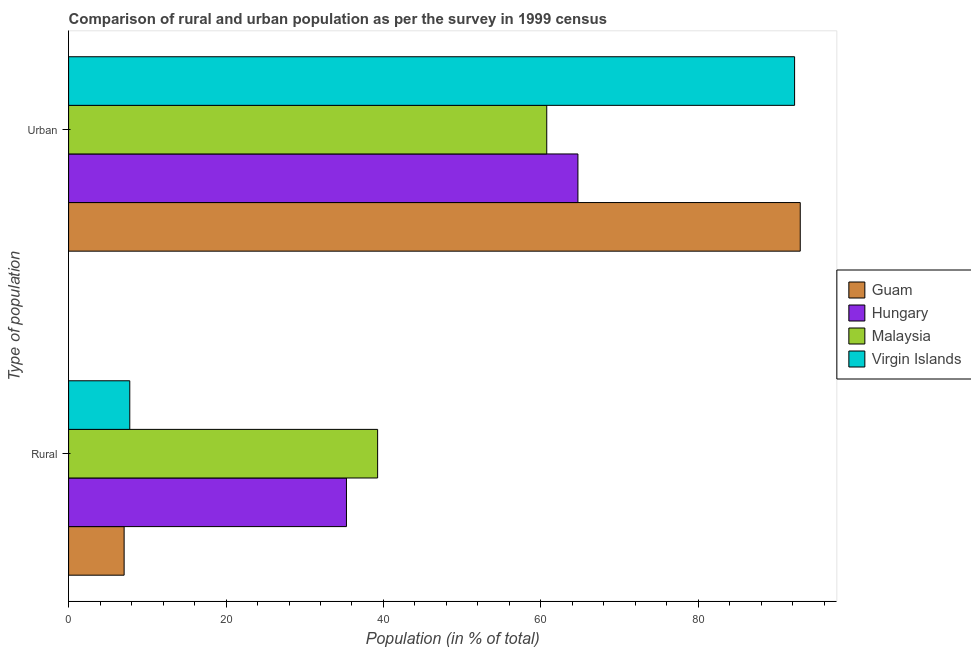How many different coloured bars are there?
Make the answer very short. 4. Are the number of bars on each tick of the Y-axis equal?
Make the answer very short. Yes. How many bars are there on the 1st tick from the top?
Your answer should be compact. 4. What is the label of the 1st group of bars from the top?
Your answer should be compact. Urban. What is the rural population in Virgin Islands?
Give a very brief answer. 7.77. Across all countries, what is the maximum rural population?
Your response must be concise. 39.26. Across all countries, what is the minimum rural population?
Your answer should be compact. 7.05. In which country was the rural population maximum?
Provide a succinct answer. Malaysia. In which country was the rural population minimum?
Offer a terse response. Guam. What is the total urban population in the graph?
Give a very brief answer. 310.62. What is the difference between the urban population in Guam and that in Hungary?
Your response must be concise. 28.24. What is the difference between the rural population in Malaysia and the urban population in Virgin Islands?
Your answer should be compact. -52.97. What is the average rural population per country?
Your answer should be compact. 22.35. What is the difference between the rural population and urban population in Guam?
Provide a short and direct response. -85.89. What is the ratio of the rural population in Hungary to that in Malaysia?
Make the answer very short. 0.9. What does the 1st bar from the top in Urban represents?
Offer a very short reply. Virgin Islands. What does the 1st bar from the bottom in Urban represents?
Make the answer very short. Guam. Are all the bars in the graph horizontal?
Your answer should be compact. Yes. What is the difference between two consecutive major ticks on the X-axis?
Ensure brevity in your answer.  20. Does the graph contain any zero values?
Ensure brevity in your answer.  No. Does the graph contain grids?
Offer a very short reply. No. Where does the legend appear in the graph?
Provide a succinct answer. Center right. How are the legend labels stacked?
Ensure brevity in your answer.  Vertical. What is the title of the graph?
Provide a short and direct response. Comparison of rural and urban population as per the survey in 1999 census. What is the label or title of the X-axis?
Ensure brevity in your answer.  Population (in % of total). What is the label or title of the Y-axis?
Your answer should be compact. Type of population. What is the Population (in % of total) in Guam in Rural?
Offer a terse response. 7.05. What is the Population (in % of total) of Hungary in Rural?
Give a very brief answer. 35.3. What is the Population (in % of total) of Malaysia in Rural?
Your response must be concise. 39.26. What is the Population (in % of total) of Virgin Islands in Rural?
Your response must be concise. 7.77. What is the Population (in % of total) in Guam in Urban?
Ensure brevity in your answer.  92.95. What is the Population (in % of total) of Hungary in Urban?
Your answer should be compact. 64.7. What is the Population (in % of total) of Malaysia in Urban?
Provide a short and direct response. 60.74. What is the Population (in % of total) in Virgin Islands in Urban?
Offer a very short reply. 92.23. Across all Type of population, what is the maximum Population (in % of total) in Guam?
Offer a very short reply. 92.95. Across all Type of population, what is the maximum Population (in % of total) of Hungary?
Provide a short and direct response. 64.7. Across all Type of population, what is the maximum Population (in % of total) in Malaysia?
Your response must be concise. 60.74. Across all Type of population, what is the maximum Population (in % of total) of Virgin Islands?
Provide a short and direct response. 92.23. Across all Type of population, what is the minimum Population (in % of total) of Guam?
Your response must be concise. 7.05. Across all Type of population, what is the minimum Population (in % of total) of Hungary?
Keep it short and to the point. 35.3. Across all Type of population, what is the minimum Population (in % of total) of Malaysia?
Your response must be concise. 39.26. Across all Type of population, what is the minimum Population (in % of total) in Virgin Islands?
Keep it short and to the point. 7.77. What is the total Population (in % of total) in Hungary in the graph?
Provide a short and direct response. 100. What is the difference between the Population (in % of total) in Guam in Rural and that in Urban?
Provide a succinct answer. -85.89. What is the difference between the Population (in % of total) of Hungary in Rural and that in Urban?
Give a very brief answer. -29.4. What is the difference between the Population (in % of total) in Malaysia in Rural and that in Urban?
Provide a succinct answer. -21.48. What is the difference between the Population (in % of total) in Virgin Islands in Rural and that in Urban?
Make the answer very short. -84.46. What is the difference between the Population (in % of total) in Guam in Rural and the Population (in % of total) in Hungary in Urban?
Make the answer very short. -57.65. What is the difference between the Population (in % of total) of Guam in Rural and the Population (in % of total) of Malaysia in Urban?
Provide a succinct answer. -53.69. What is the difference between the Population (in % of total) of Guam in Rural and the Population (in % of total) of Virgin Islands in Urban?
Make the answer very short. -85.17. What is the difference between the Population (in % of total) of Hungary in Rural and the Population (in % of total) of Malaysia in Urban?
Give a very brief answer. -25.44. What is the difference between the Population (in % of total) in Hungary in Rural and the Population (in % of total) in Virgin Islands in Urban?
Ensure brevity in your answer.  -56.93. What is the difference between the Population (in % of total) in Malaysia in Rural and the Population (in % of total) in Virgin Islands in Urban?
Provide a short and direct response. -52.97. What is the average Population (in % of total) of Hungary per Type of population?
Provide a succinct answer. 50. What is the difference between the Population (in % of total) in Guam and Population (in % of total) in Hungary in Rural?
Offer a terse response. -28.24. What is the difference between the Population (in % of total) of Guam and Population (in % of total) of Malaysia in Rural?
Your response must be concise. -32.2. What is the difference between the Population (in % of total) in Guam and Population (in % of total) in Virgin Islands in Rural?
Give a very brief answer. -0.72. What is the difference between the Population (in % of total) of Hungary and Population (in % of total) of Malaysia in Rural?
Offer a terse response. -3.96. What is the difference between the Population (in % of total) in Hungary and Population (in % of total) in Virgin Islands in Rural?
Make the answer very short. 27.53. What is the difference between the Population (in % of total) in Malaysia and Population (in % of total) in Virgin Islands in Rural?
Your answer should be very brief. 31.49. What is the difference between the Population (in % of total) in Guam and Population (in % of total) in Hungary in Urban?
Offer a very short reply. 28.24. What is the difference between the Population (in % of total) in Guam and Population (in % of total) in Malaysia in Urban?
Keep it short and to the point. 32.2. What is the difference between the Population (in % of total) of Guam and Population (in % of total) of Virgin Islands in Urban?
Offer a very short reply. 0.72. What is the difference between the Population (in % of total) of Hungary and Population (in % of total) of Malaysia in Urban?
Your answer should be compact. 3.96. What is the difference between the Population (in % of total) in Hungary and Population (in % of total) in Virgin Islands in Urban?
Ensure brevity in your answer.  -27.53. What is the difference between the Population (in % of total) in Malaysia and Population (in % of total) in Virgin Islands in Urban?
Provide a short and direct response. -31.49. What is the ratio of the Population (in % of total) of Guam in Rural to that in Urban?
Provide a short and direct response. 0.08. What is the ratio of the Population (in % of total) of Hungary in Rural to that in Urban?
Offer a very short reply. 0.55. What is the ratio of the Population (in % of total) of Malaysia in Rural to that in Urban?
Provide a short and direct response. 0.65. What is the ratio of the Population (in % of total) in Virgin Islands in Rural to that in Urban?
Provide a short and direct response. 0.08. What is the difference between the highest and the second highest Population (in % of total) in Guam?
Ensure brevity in your answer.  85.89. What is the difference between the highest and the second highest Population (in % of total) in Hungary?
Your answer should be compact. 29.4. What is the difference between the highest and the second highest Population (in % of total) of Malaysia?
Give a very brief answer. 21.48. What is the difference between the highest and the second highest Population (in % of total) of Virgin Islands?
Your answer should be very brief. 84.46. What is the difference between the highest and the lowest Population (in % of total) of Guam?
Ensure brevity in your answer.  85.89. What is the difference between the highest and the lowest Population (in % of total) of Hungary?
Provide a succinct answer. 29.4. What is the difference between the highest and the lowest Population (in % of total) in Malaysia?
Your answer should be very brief. 21.48. What is the difference between the highest and the lowest Population (in % of total) in Virgin Islands?
Offer a very short reply. 84.46. 